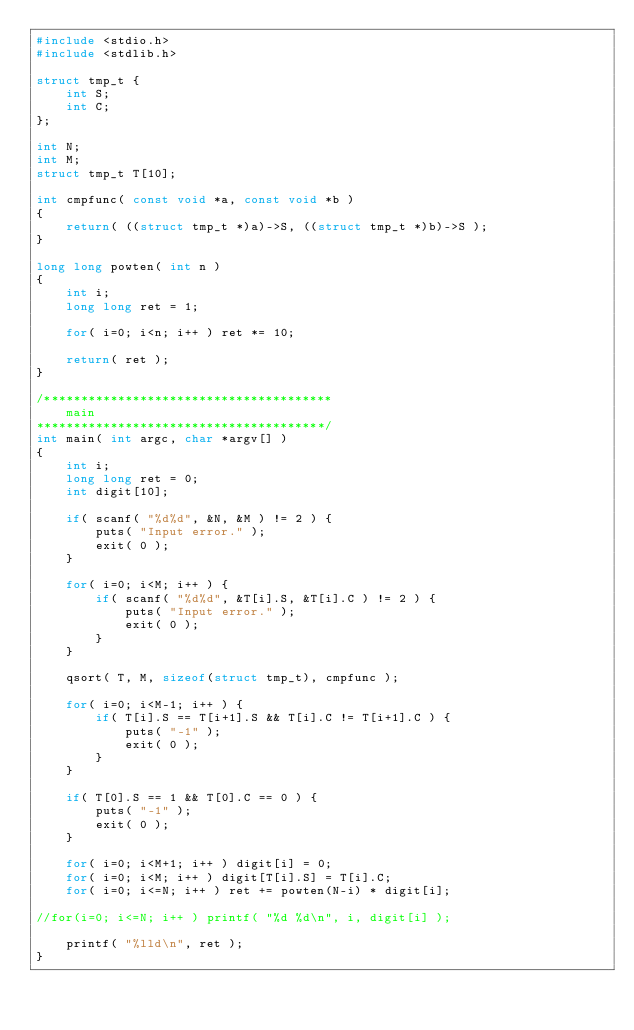Convert code to text. <code><loc_0><loc_0><loc_500><loc_500><_C_>#include <stdio.h>
#include <stdlib.h>

struct tmp_t {
    int S;
    int C;
};

int N;
int M;
struct tmp_t T[10];

int cmpfunc( const void *a, const void *b )
{
    return( ((struct tmp_t *)a)->S, ((struct tmp_t *)b)->S );
}

long long powten( int n )
{
    int i;
    long long ret = 1;

    for( i=0; i<n; i++ ) ret *= 10;

    return( ret );
}

/***************************************
    main
***************************************/
int main( int argc, char *argv[] )
{
    int i;
    long long ret = 0;
    int digit[10];

    if( scanf( "%d%d", &N, &M ) != 2 ) {
        puts( "Input error." );
        exit( 0 );
    }

    for( i=0; i<M; i++ ) {
        if( scanf( "%d%d", &T[i].S, &T[i].C ) != 2 ) {
            puts( "Input error." );
            exit( 0 );
        }
    }

    qsort( T, M, sizeof(struct tmp_t), cmpfunc );

    for( i=0; i<M-1; i++ ) {
        if( T[i].S == T[i+1].S && T[i].C != T[i+1].C ) {
            puts( "-1" );
            exit( 0 );
        }
    }

    if( T[0].S == 1 && T[0].C == 0 ) {
        puts( "-1" );
        exit( 0 );
    }

    for( i=0; i<M+1; i++ ) digit[i] = 0;
    for( i=0; i<M; i++ ) digit[T[i].S] = T[i].C;
    for( i=0; i<=N; i++ ) ret += powten(N-i) * digit[i];

//for(i=0; i<=N; i++ ) printf( "%d %d\n", i, digit[i] );

    printf( "%lld\n", ret );
}
</code> 